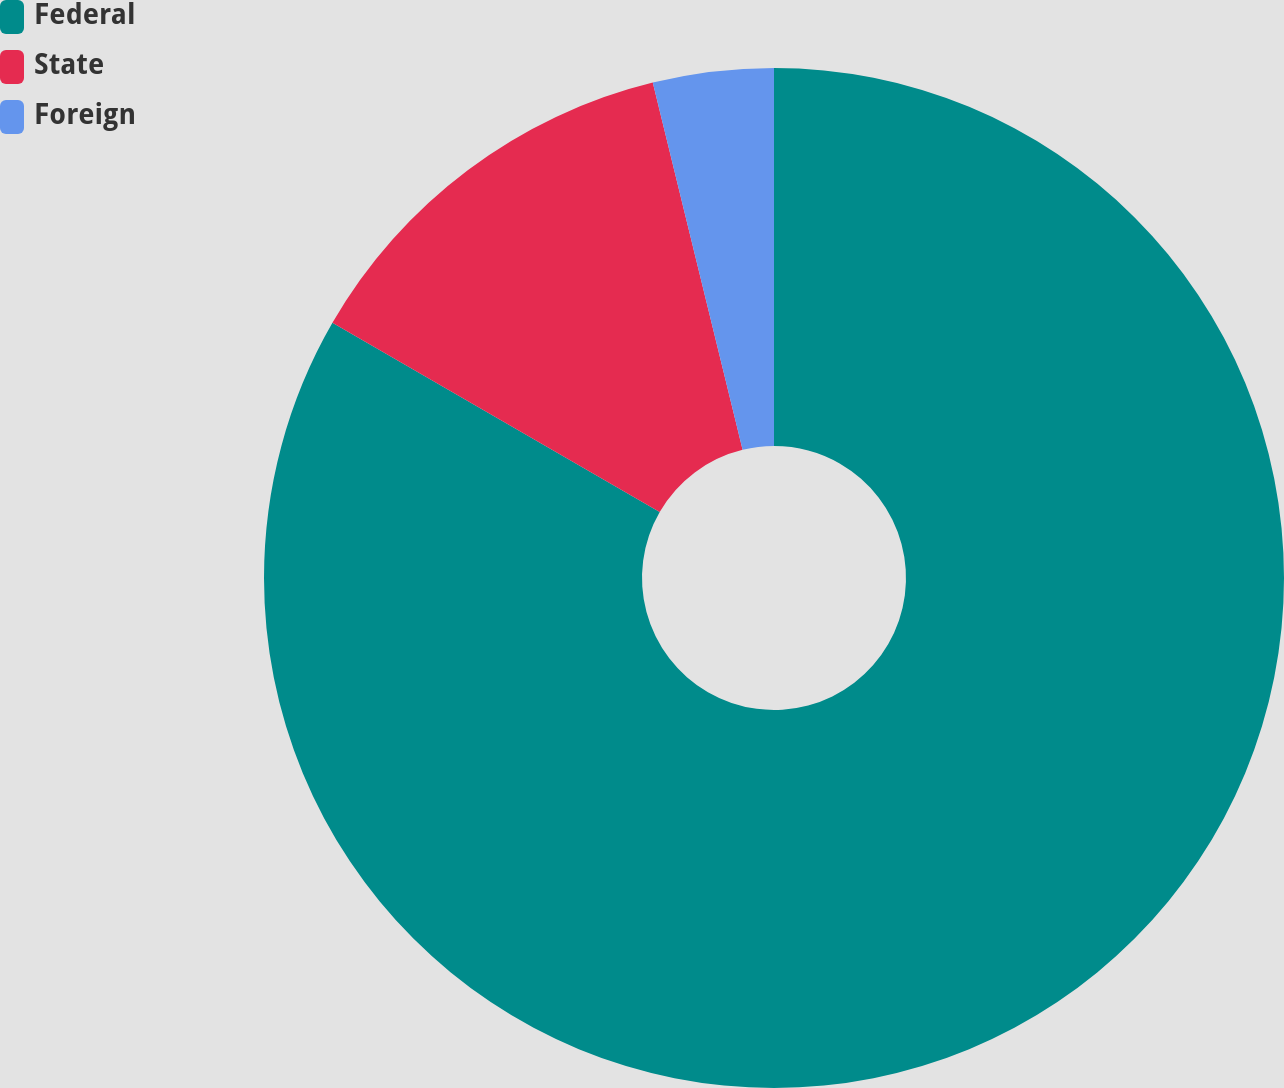Convert chart. <chart><loc_0><loc_0><loc_500><loc_500><pie_chart><fcel>Federal<fcel>State<fcel>Foreign<nl><fcel>83.34%<fcel>12.84%<fcel>3.82%<nl></chart> 